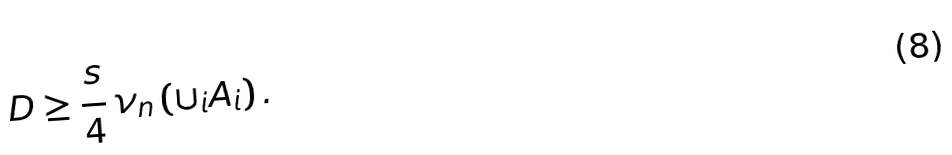<formula> <loc_0><loc_0><loc_500><loc_500>D \geq \frac { s } { 4 } \, \nu _ { n } \left ( \cup _ { i } A _ { i } \right ) .</formula> 